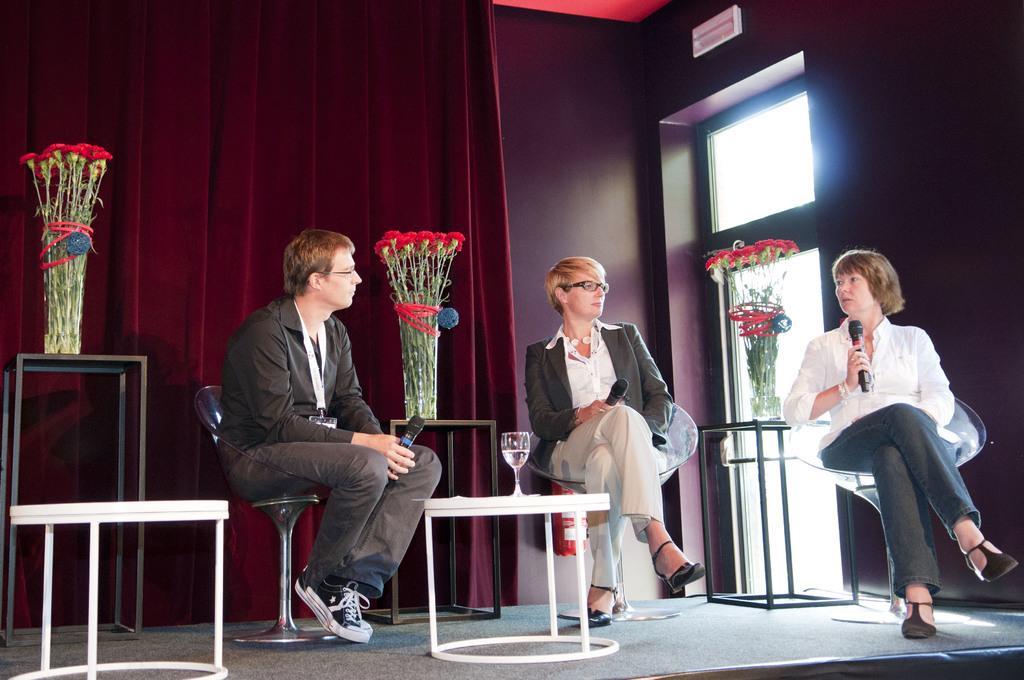Could you give a brief overview of what you see in this image? There are group of persons who are sitting on the chairs holding microphones in their hands and there are flower vases and glass and at the background of the image there is a curtain. 